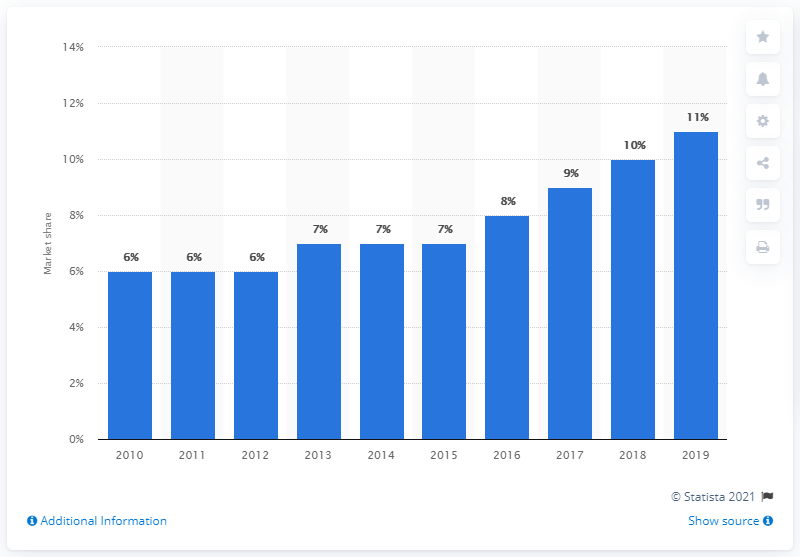Draw attention to some important aspects in this diagram. In 2010, no or low calorie drinks accounted for approximately 11% of Italy's soft drink market. In 2019, the market share of no or low calorie drinks in Italy was approximately 11%. 